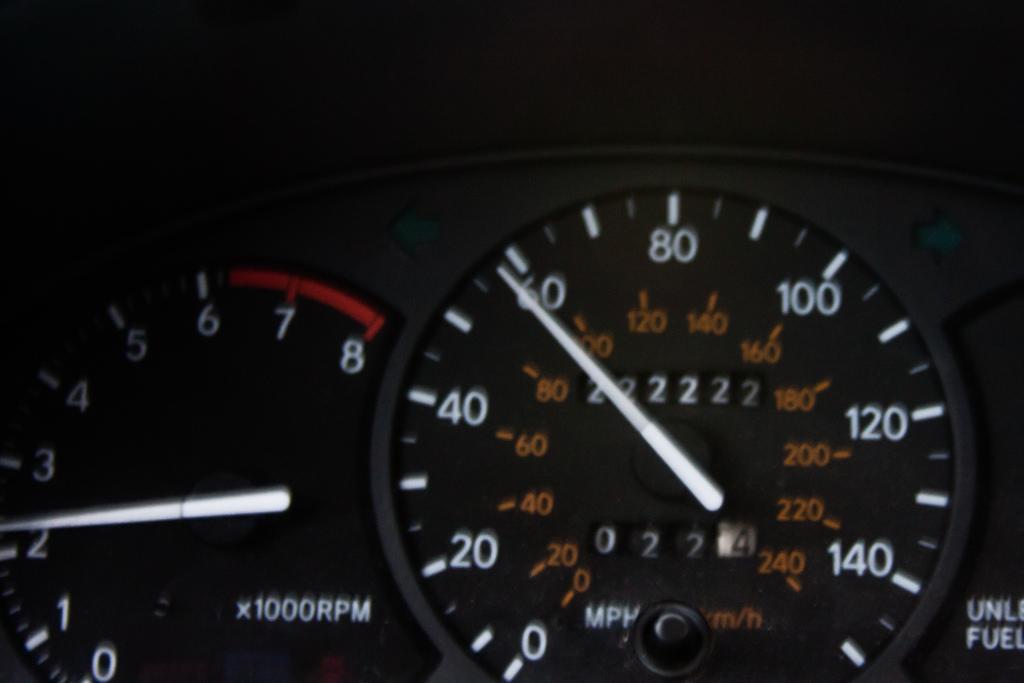Could you give a brief overview of what you see in this image? In this image we can see a dash gauge. 